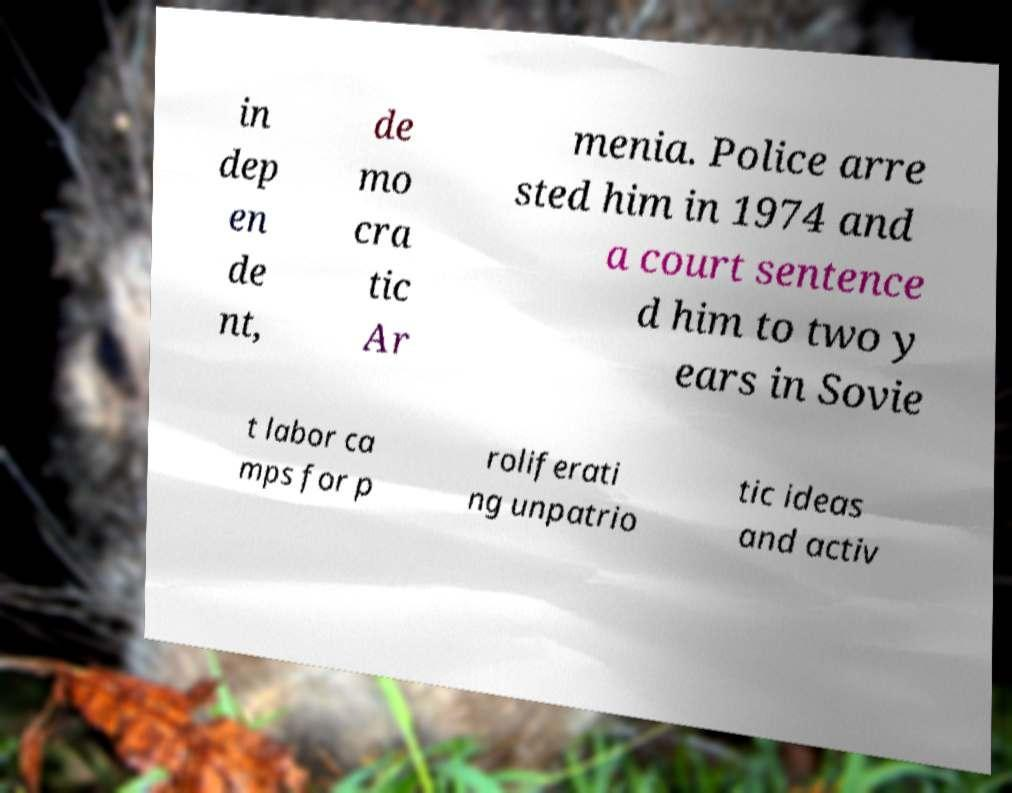Can you read and provide the text displayed in the image?This photo seems to have some interesting text. Can you extract and type it out for me? in dep en de nt, de mo cra tic Ar menia. Police arre sted him in 1974 and a court sentence d him to two y ears in Sovie t labor ca mps for p roliferati ng unpatrio tic ideas and activ 